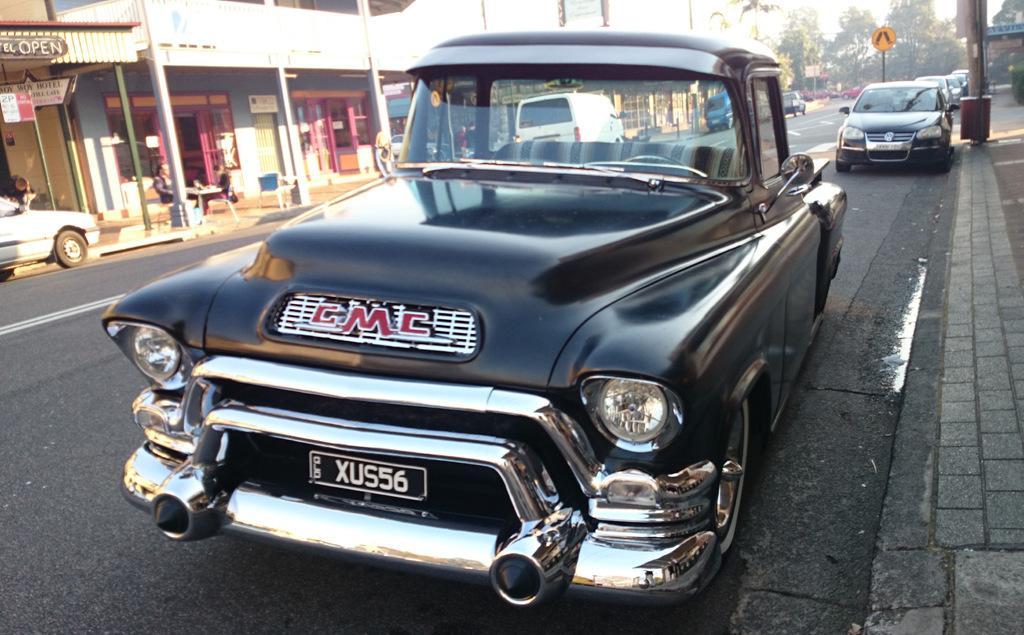How would you summarize this image in a sentence or two? The picture is taken outside a city, on the streets. In the foreground of the picture on the road there are cars. On the left there are buildings, tables and chairs. On the right there is a footpath, pole and plant. In the background there are trees and sign boards. 